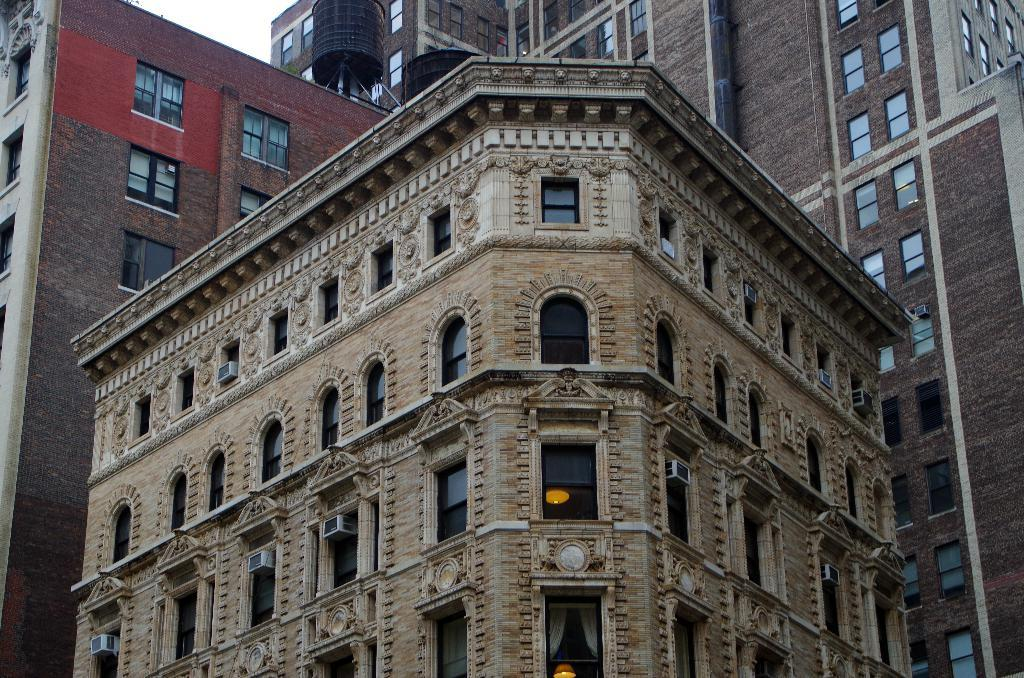What type of structures are present in the image? There are tall buildings in the picture. What feature is prominent on the buildings? The buildings have a lot of windows. What type of insurance policy is being discussed by the band in the image? There is no band or discussion of insurance policies present in the image. 